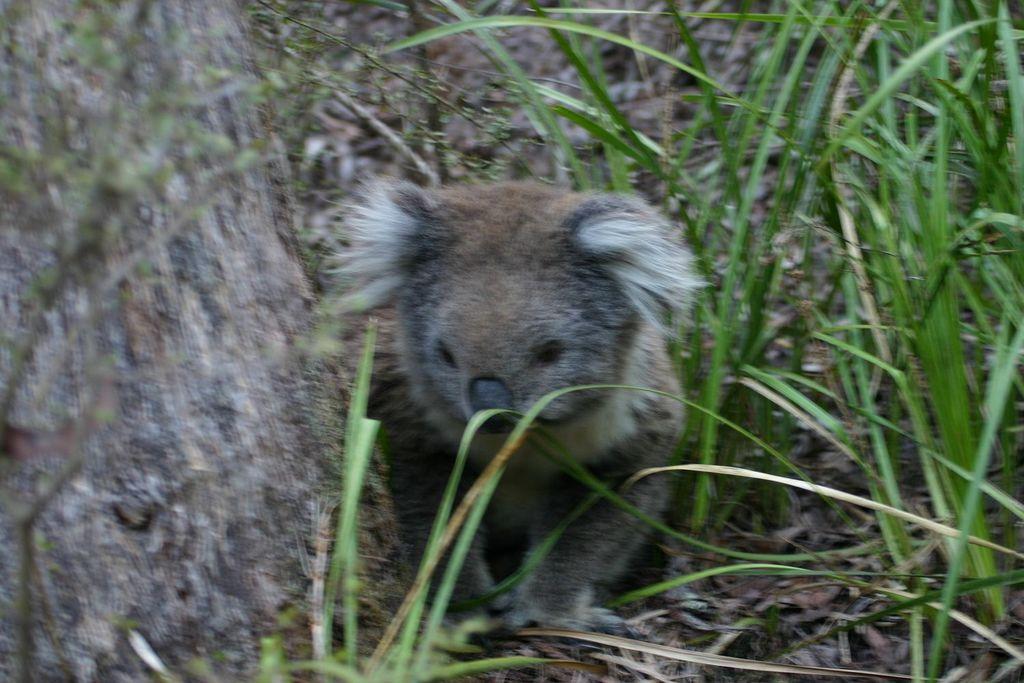Can you describe this image briefly? In the image there is a small animal beside the grass, it is laying on the ground. 